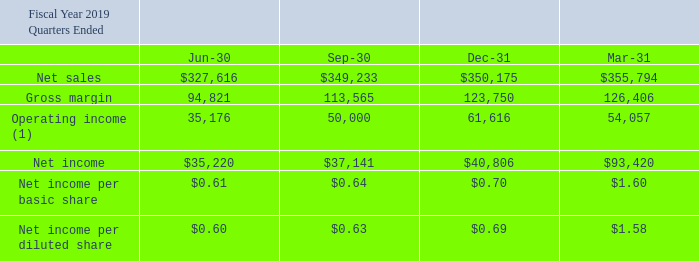Note 16: Quarterly Results of Operations (Unaudited)
The following table sets forth certain quarterly information for fiscal years 2019 and 2018. This information, in the opinion of the Company’s management, reflects all adjustments (consisting only of normal recurring adjustments) necessary to present fairly this information when read in conjunction with the Consolidated Financial Statements and notes thereto included elsewhere herein (amounts in thousands except per share data):
(1) Operating income (loss) as a percentage of net sales fluctuates from quarter to quarter due to a number of factors, including net sales fluctuations, foreign currency exchange, restructuring charges, product mix, the timing and expense of moving product lines to lower-cost locations, the write-down of long lived assets, the net gain/loss on sales and disposals of assets and the relative mix of sales among distributors, original equipment manufacturers, and electronic manufacturing service providers.
What was the net sales for the Jun-30 quarter?
Answer scale should be: thousand. 327,616. What was the gross margin for the Sep-30 quarter?
Answer scale should be: thousand. 113,565. What was the operating income for the Mar-31 quarter?
Answer scale should be: thousand. 54,057. What was the change in the Net sales between the Dec-31 and Mar-31 quarters?
Answer scale should be: thousand. 355,794-350,175
Answer: 5619. Which quarters ended did the Gross Margin exceed $120,000 thousand? (Dec-31:123,750),(Mar-31:126,406)
Answer: dec-31, mar-31. What was the percentage change in the net income between the Jun-30 and Sep-30 quarter?
Answer scale should be: percent. (37,141-35,220)/35,220
Answer: 5.45. 